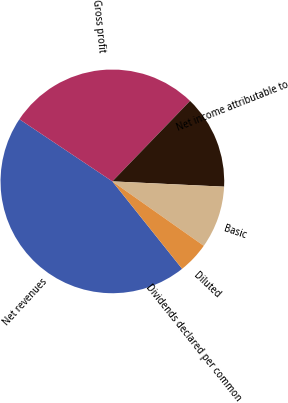Convert chart to OTSL. <chart><loc_0><loc_0><loc_500><loc_500><pie_chart><fcel>Net revenues<fcel>Gross profit<fcel>Net income attributable to<fcel>Basic<fcel>Diluted<fcel>Dividends declared per common<nl><fcel>45.09%<fcel>27.84%<fcel>13.53%<fcel>9.02%<fcel>4.51%<fcel>0.0%<nl></chart> 